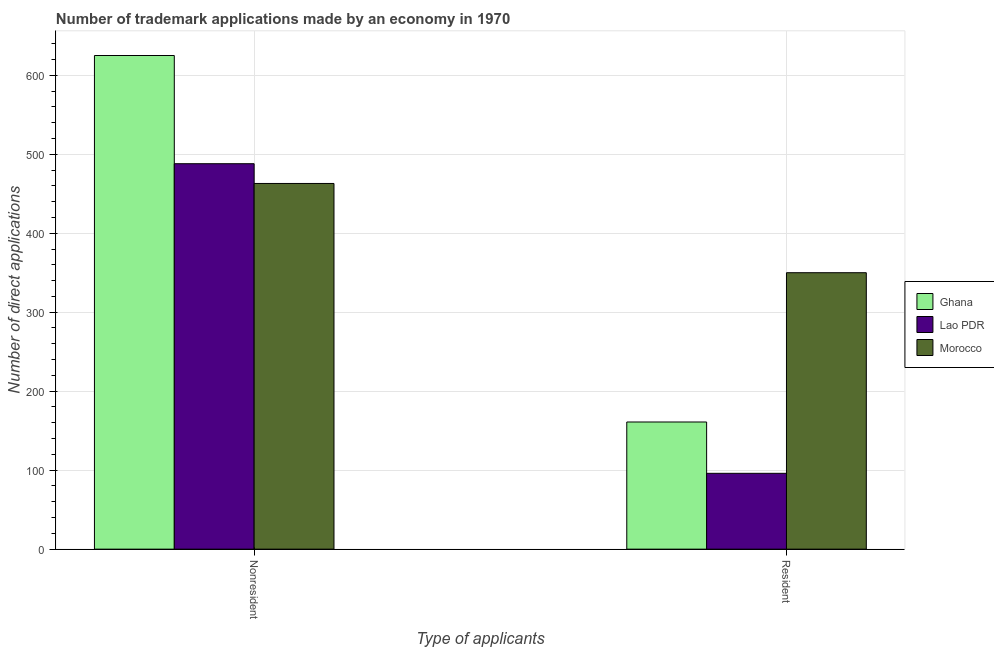How many groups of bars are there?
Your answer should be compact. 2. Are the number of bars per tick equal to the number of legend labels?
Offer a terse response. Yes. Are the number of bars on each tick of the X-axis equal?
Your answer should be very brief. Yes. How many bars are there on the 1st tick from the right?
Give a very brief answer. 3. What is the label of the 1st group of bars from the left?
Ensure brevity in your answer.  Nonresident. What is the number of trademark applications made by non residents in Lao PDR?
Make the answer very short. 488. Across all countries, what is the maximum number of trademark applications made by non residents?
Give a very brief answer. 625. Across all countries, what is the minimum number of trademark applications made by residents?
Provide a succinct answer. 96. In which country was the number of trademark applications made by non residents maximum?
Make the answer very short. Ghana. In which country was the number of trademark applications made by residents minimum?
Make the answer very short. Lao PDR. What is the total number of trademark applications made by residents in the graph?
Make the answer very short. 607. What is the difference between the number of trademark applications made by non residents in Ghana and that in Lao PDR?
Your answer should be compact. 137. What is the difference between the number of trademark applications made by residents in Lao PDR and the number of trademark applications made by non residents in Ghana?
Keep it short and to the point. -529. What is the average number of trademark applications made by non residents per country?
Provide a succinct answer. 525.33. What is the difference between the number of trademark applications made by non residents and number of trademark applications made by residents in Morocco?
Your response must be concise. 113. What is the ratio of the number of trademark applications made by non residents in Ghana to that in Morocco?
Make the answer very short. 1.35. What does the 2nd bar from the left in Resident represents?
Your response must be concise. Lao PDR. What does the 1st bar from the right in Resident represents?
Provide a succinct answer. Morocco. Are all the bars in the graph horizontal?
Provide a succinct answer. No. How many countries are there in the graph?
Your answer should be very brief. 3. What is the difference between two consecutive major ticks on the Y-axis?
Offer a very short reply. 100. How many legend labels are there?
Keep it short and to the point. 3. What is the title of the graph?
Give a very brief answer. Number of trademark applications made by an economy in 1970. Does "Vietnam" appear as one of the legend labels in the graph?
Provide a succinct answer. No. What is the label or title of the X-axis?
Provide a succinct answer. Type of applicants. What is the label or title of the Y-axis?
Ensure brevity in your answer.  Number of direct applications. What is the Number of direct applications of Ghana in Nonresident?
Make the answer very short. 625. What is the Number of direct applications of Lao PDR in Nonresident?
Keep it short and to the point. 488. What is the Number of direct applications of Morocco in Nonresident?
Your answer should be very brief. 463. What is the Number of direct applications of Ghana in Resident?
Provide a succinct answer. 161. What is the Number of direct applications of Lao PDR in Resident?
Your answer should be very brief. 96. What is the Number of direct applications of Morocco in Resident?
Your response must be concise. 350. Across all Type of applicants, what is the maximum Number of direct applications of Ghana?
Your response must be concise. 625. Across all Type of applicants, what is the maximum Number of direct applications in Lao PDR?
Your answer should be very brief. 488. Across all Type of applicants, what is the maximum Number of direct applications in Morocco?
Give a very brief answer. 463. Across all Type of applicants, what is the minimum Number of direct applications in Ghana?
Offer a very short reply. 161. Across all Type of applicants, what is the minimum Number of direct applications of Lao PDR?
Make the answer very short. 96. Across all Type of applicants, what is the minimum Number of direct applications of Morocco?
Your answer should be compact. 350. What is the total Number of direct applications of Ghana in the graph?
Give a very brief answer. 786. What is the total Number of direct applications in Lao PDR in the graph?
Your answer should be compact. 584. What is the total Number of direct applications of Morocco in the graph?
Your answer should be very brief. 813. What is the difference between the Number of direct applications of Ghana in Nonresident and that in Resident?
Your answer should be compact. 464. What is the difference between the Number of direct applications of Lao PDR in Nonresident and that in Resident?
Offer a terse response. 392. What is the difference between the Number of direct applications of Morocco in Nonresident and that in Resident?
Offer a terse response. 113. What is the difference between the Number of direct applications of Ghana in Nonresident and the Number of direct applications of Lao PDR in Resident?
Your answer should be compact. 529. What is the difference between the Number of direct applications in Ghana in Nonresident and the Number of direct applications in Morocco in Resident?
Your answer should be very brief. 275. What is the difference between the Number of direct applications of Lao PDR in Nonresident and the Number of direct applications of Morocco in Resident?
Give a very brief answer. 138. What is the average Number of direct applications in Ghana per Type of applicants?
Provide a succinct answer. 393. What is the average Number of direct applications in Lao PDR per Type of applicants?
Provide a succinct answer. 292. What is the average Number of direct applications of Morocco per Type of applicants?
Provide a succinct answer. 406.5. What is the difference between the Number of direct applications in Ghana and Number of direct applications in Lao PDR in Nonresident?
Your response must be concise. 137. What is the difference between the Number of direct applications of Ghana and Number of direct applications of Morocco in Nonresident?
Your answer should be very brief. 162. What is the difference between the Number of direct applications in Lao PDR and Number of direct applications in Morocco in Nonresident?
Give a very brief answer. 25. What is the difference between the Number of direct applications of Ghana and Number of direct applications of Lao PDR in Resident?
Offer a terse response. 65. What is the difference between the Number of direct applications in Ghana and Number of direct applications in Morocco in Resident?
Ensure brevity in your answer.  -189. What is the difference between the Number of direct applications in Lao PDR and Number of direct applications in Morocco in Resident?
Ensure brevity in your answer.  -254. What is the ratio of the Number of direct applications of Ghana in Nonresident to that in Resident?
Ensure brevity in your answer.  3.88. What is the ratio of the Number of direct applications in Lao PDR in Nonresident to that in Resident?
Offer a terse response. 5.08. What is the ratio of the Number of direct applications in Morocco in Nonresident to that in Resident?
Provide a short and direct response. 1.32. What is the difference between the highest and the second highest Number of direct applications of Ghana?
Ensure brevity in your answer.  464. What is the difference between the highest and the second highest Number of direct applications of Lao PDR?
Provide a succinct answer. 392. What is the difference between the highest and the second highest Number of direct applications in Morocco?
Offer a very short reply. 113. What is the difference between the highest and the lowest Number of direct applications of Ghana?
Offer a very short reply. 464. What is the difference between the highest and the lowest Number of direct applications in Lao PDR?
Keep it short and to the point. 392. What is the difference between the highest and the lowest Number of direct applications of Morocco?
Offer a very short reply. 113. 